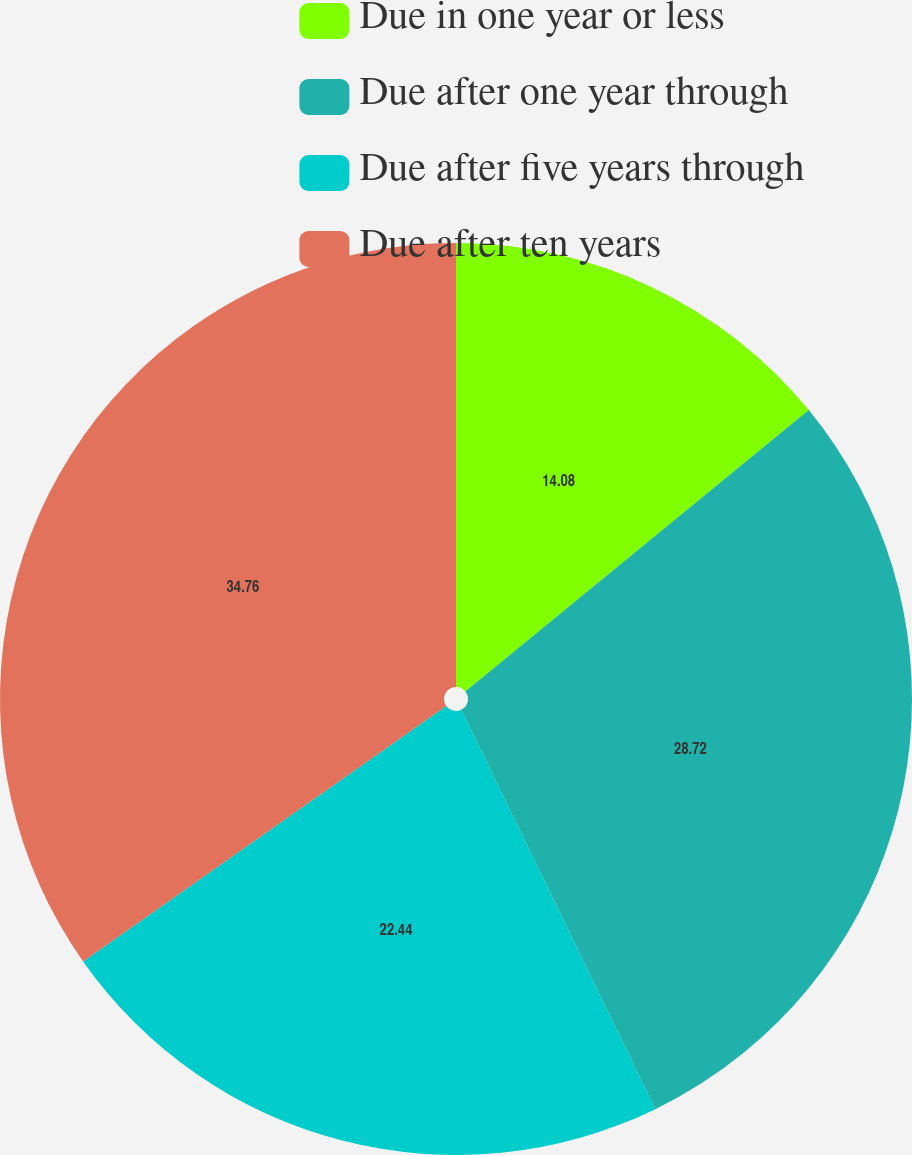<chart> <loc_0><loc_0><loc_500><loc_500><pie_chart><fcel>Due in one year or less<fcel>Due after one year through<fcel>Due after five years through<fcel>Due after ten years<nl><fcel>14.08%<fcel>28.72%<fcel>22.44%<fcel>34.76%<nl></chart> 